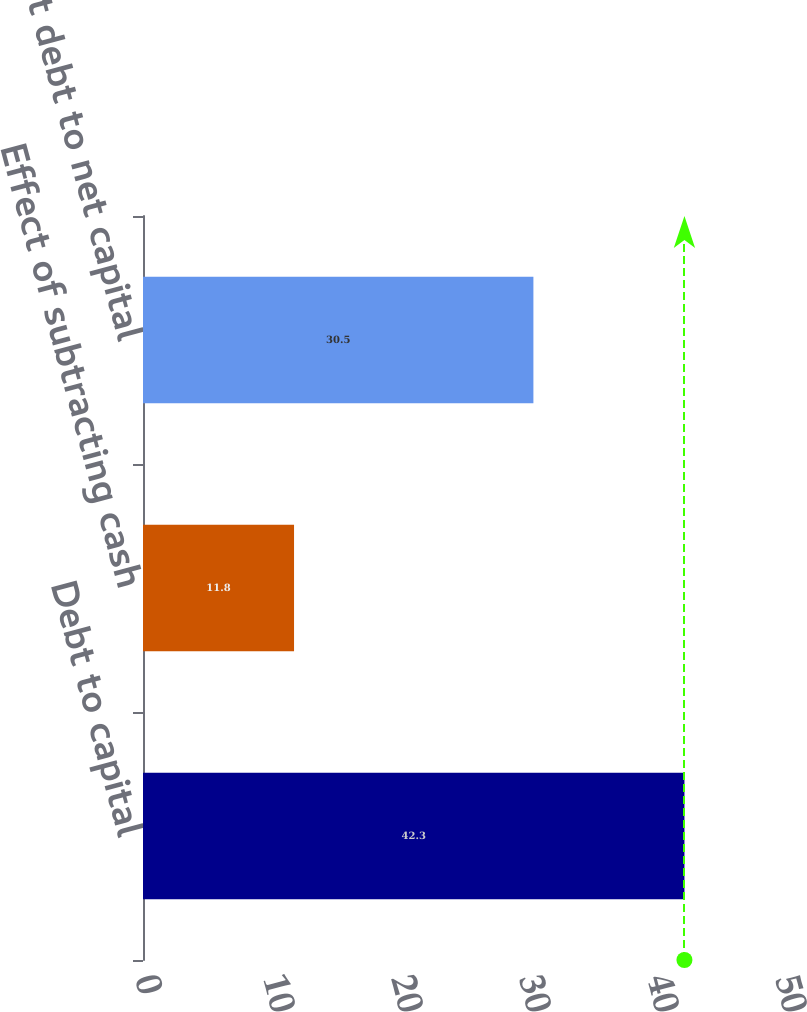<chart> <loc_0><loc_0><loc_500><loc_500><bar_chart><fcel>Debt to capital<fcel>Effect of subtracting cash<fcel>Net debt to net capital<nl><fcel>42.3<fcel>11.8<fcel>30.5<nl></chart> 